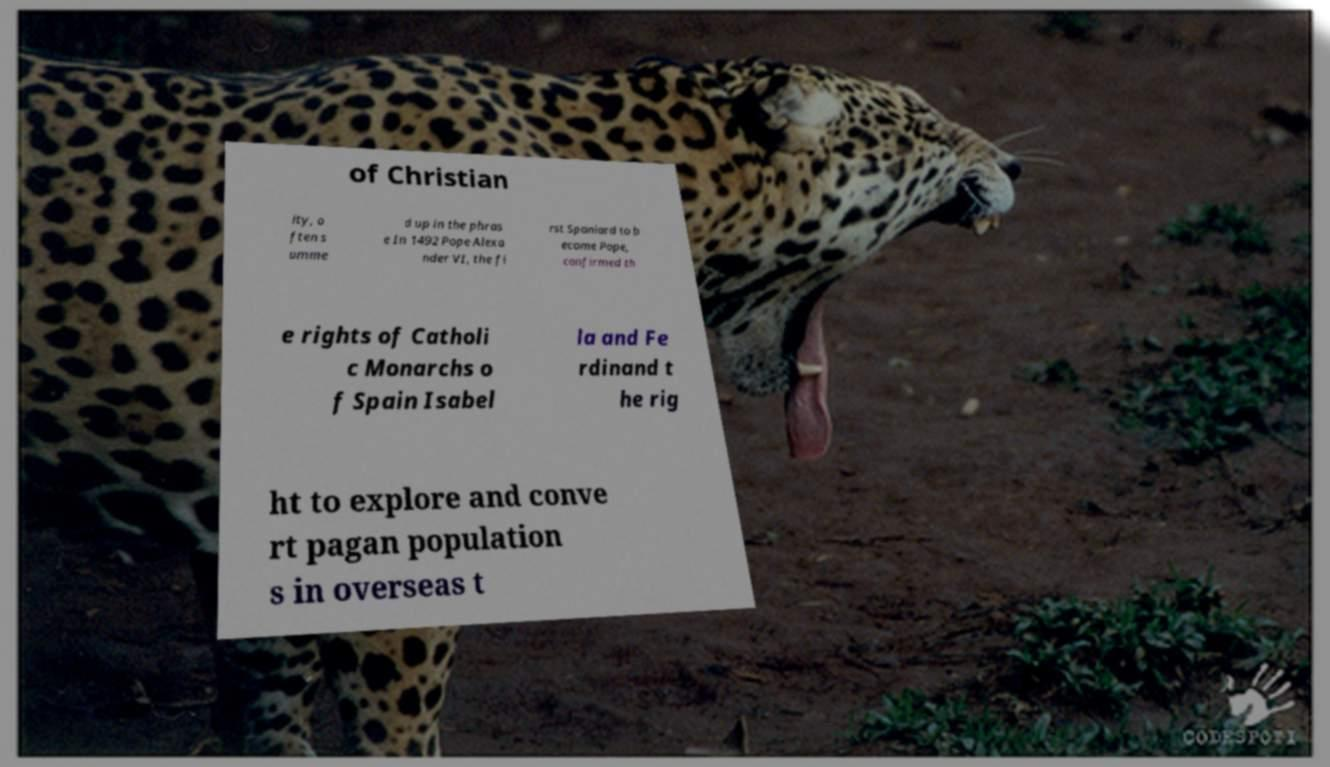Could you extract and type out the text from this image? of Christian ity, o ften s umme d up in the phras e In 1492 Pope Alexa nder VI, the fi rst Spaniard to b ecome Pope, confirmed th e rights of Catholi c Monarchs o f Spain Isabel la and Fe rdinand t he rig ht to explore and conve rt pagan population s in overseas t 